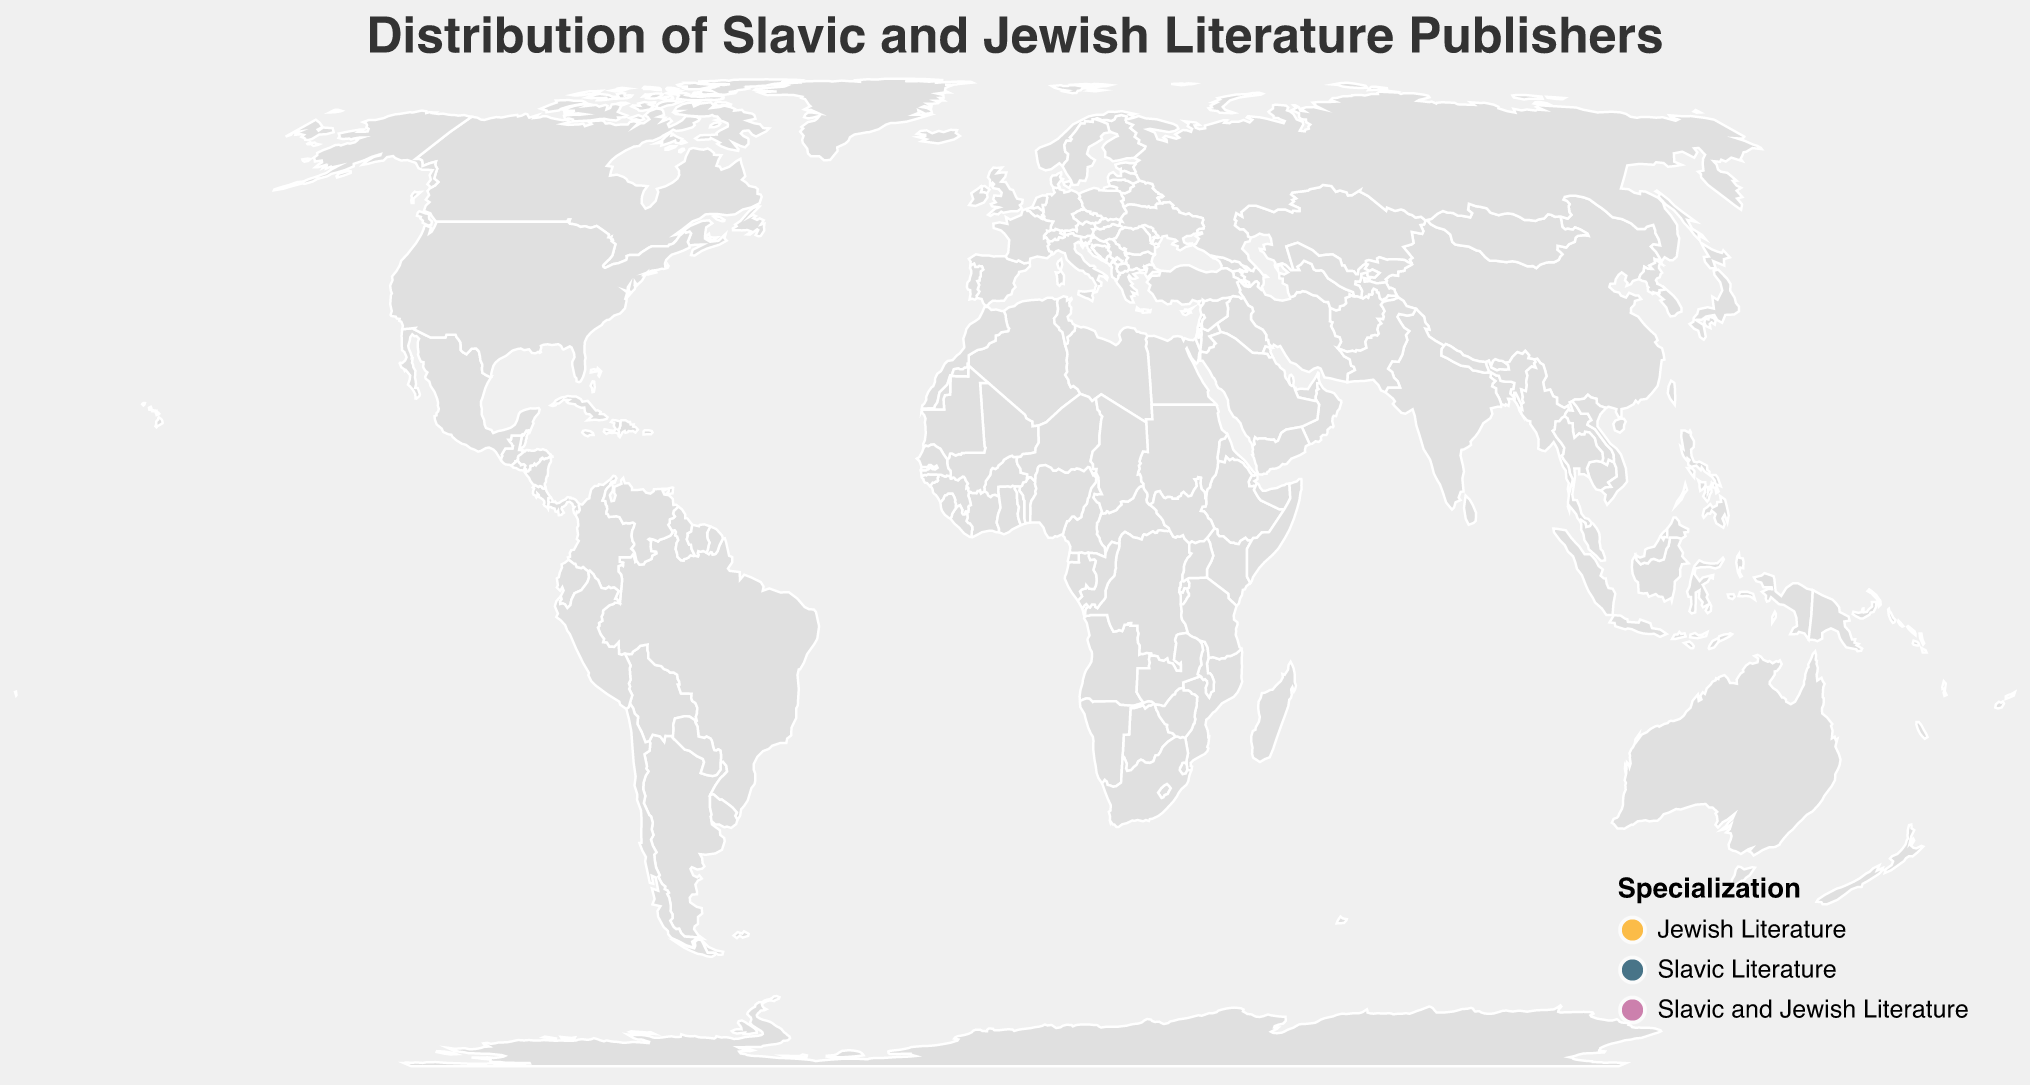What's the title of the plot? The title is usually prominent and located at the top of the plot. It summarizes the figure's content.
Answer: Distribution of Slavic and Jewish Literature Publishers Which city has the publishing house with the highest market share? Review the circles on the plot, including their size and market share percentage in the tooltip to identify the largest market share.
Answer: New York How many publishing houses focus solely on Jewish Literature? Check the color legend and count the circles with the color that corresponds to Jewish Literature.
Answer: 4 Which publishing house in Europe has the highest market share for Slavic Literature? Identify the European cities, filter for Slavic Literature, and find the largest market share.
Answer: Glagoslav Publications in Moscow Are there more publishing houses specializing in Slavic Literature or Jewish Literature? Count the circles colored for Slavic Literature and Jewish Literature respectively, based on the legend.
Answer: Slavic Literature What is the combined market share of publishers specializing in both Slavic and Jewish Literature? Sum the market share percentages of publishing houses with the specialization "Slavic and Jewish Literature."
Answer: 14.1% Which country has the most diverse specialization in publishing houses? Identify countries with the highest number of distinct specializations, checking different colors in the legend for each country.
Answer: USA Compare the market share of De Gruyter and Academic Studies Press. Which one is higher? Look at each publisher's city, then their market share via the tooltip, and compare the numbers.
Answer: De Gruyter What’s the average market share for publishing houses in North America? Sum the market share percentages of North American publishers and divide by their number.
Answer: 4.85% Which city hosts the publishing house named "Schocken Books" and what is its specialization? Locate "Schocken Books" on the plot using tooltips and identify its city and specialization.
Answer: New York, Jewish Literature 